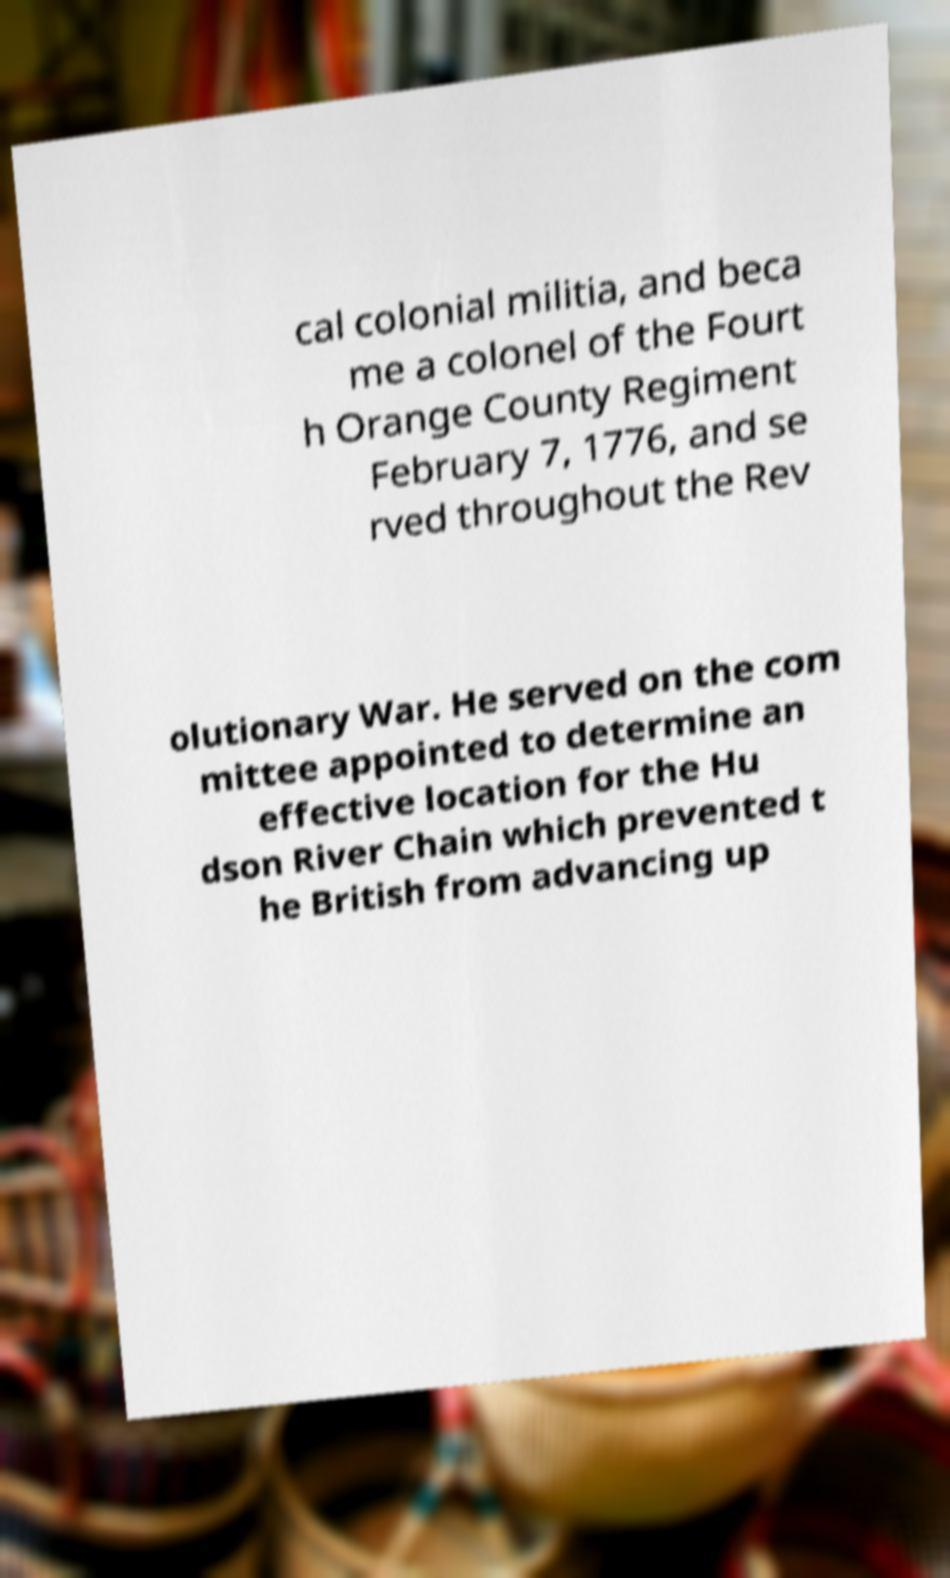What messages or text are displayed in this image? I need them in a readable, typed format. cal colonial militia, and beca me a colonel of the Fourt h Orange County Regiment February 7, 1776, and se rved throughout the Rev olutionary War. He served on the com mittee appointed to determine an effective location for the Hu dson River Chain which prevented t he British from advancing up 